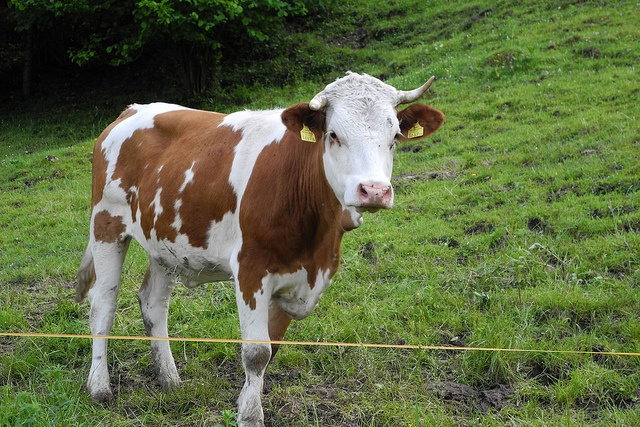Describe the objects in this image and their specific colors. I can see a cow in black, darkgray, lightgray, and maroon tones in this image. 